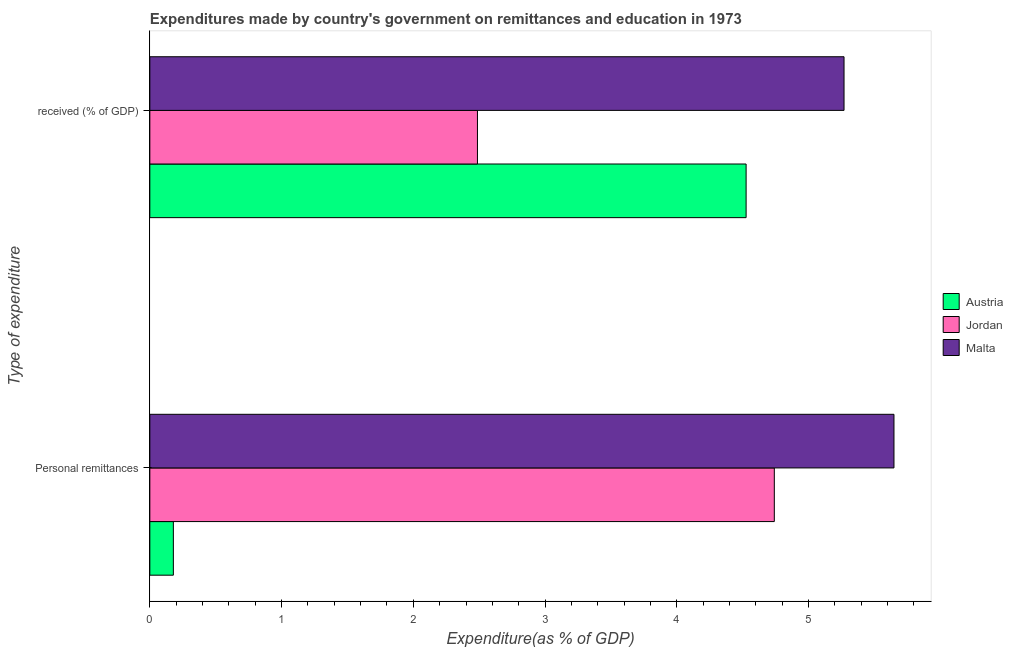How many groups of bars are there?
Provide a succinct answer. 2. Are the number of bars per tick equal to the number of legend labels?
Provide a short and direct response. Yes. How many bars are there on the 2nd tick from the top?
Offer a terse response. 3. What is the label of the 2nd group of bars from the top?
Your response must be concise. Personal remittances. What is the expenditure in education in Malta?
Your response must be concise. 5.27. Across all countries, what is the maximum expenditure in education?
Keep it short and to the point. 5.27. Across all countries, what is the minimum expenditure in personal remittances?
Offer a terse response. 0.18. In which country was the expenditure in education maximum?
Offer a terse response. Malta. In which country was the expenditure in personal remittances minimum?
Provide a succinct answer. Austria. What is the total expenditure in education in the graph?
Your response must be concise. 12.28. What is the difference between the expenditure in personal remittances in Malta and that in Austria?
Offer a terse response. 5.47. What is the difference between the expenditure in personal remittances in Jordan and the expenditure in education in Malta?
Provide a succinct answer. -0.53. What is the average expenditure in education per country?
Give a very brief answer. 4.09. What is the difference between the expenditure in education and expenditure in personal remittances in Austria?
Provide a succinct answer. 4.35. In how many countries, is the expenditure in personal remittances greater than 0.8 %?
Your response must be concise. 2. What is the ratio of the expenditure in education in Austria to that in Jordan?
Offer a terse response. 1.82. Is the expenditure in personal remittances in Malta less than that in Austria?
Give a very brief answer. No. What does the 2nd bar from the top in  received (% of GDP) represents?
Your answer should be very brief. Jordan. What does the 2nd bar from the bottom in  received (% of GDP) represents?
Your response must be concise. Jordan. How many bars are there?
Ensure brevity in your answer.  6. What is the difference between two consecutive major ticks on the X-axis?
Offer a terse response. 1. Does the graph contain grids?
Provide a short and direct response. No. How are the legend labels stacked?
Offer a very short reply. Vertical. What is the title of the graph?
Your response must be concise. Expenditures made by country's government on remittances and education in 1973. What is the label or title of the X-axis?
Give a very brief answer. Expenditure(as % of GDP). What is the label or title of the Y-axis?
Give a very brief answer. Type of expenditure. What is the Expenditure(as % of GDP) in Austria in Personal remittances?
Provide a succinct answer. 0.18. What is the Expenditure(as % of GDP) of Jordan in Personal remittances?
Ensure brevity in your answer.  4.74. What is the Expenditure(as % of GDP) of Malta in Personal remittances?
Keep it short and to the point. 5.65. What is the Expenditure(as % of GDP) of Austria in  received (% of GDP)?
Offer a terse response. 4.53. What is the Expenditure(as % of GDP) of Jordan in  received (% of GDP)?
Your answer should be very brief. 2.49. What is the Expenditure(as % of GDP) in Malta in  received (% of GDP)?
Keep it short and to the point. 5.27. Across all Type of expenditure, what is the maximum Expenditure(as % of GDP) in Austria?
Provide a succinct answer. 4.53. Across all Type of expenditure, what is the maximum Expenditure(as % of GDP) in Jordan?
Your answer should be compact. 4.74. Across all Type of expenditure, what is the maximum Expenditure(as % of GDP) of Malta?
Offer a very short reply. 5.65. Across all Type of expenditure, what is the minimum Expenditure(as % of GDP) in Austria?
Make the answer very short. 0.18. Across all Type of expenditure, what is the minimum Expenditure(as % of GDP) of Jordan?
Make the answer very short. 2.49. Across all Type of expenditure, what is the minimum Expenditure(as % of GDP) in Malta?
Offer a terse response. 5.27. What is the total Expenditure(as % of GDP) of Austria in the graph?
Your answer should be compact. 4.71. What is the total Expenditure(as % of GDP) in Jordan in the graph?
Make the answer very short. 7.23. What is the total Expenditure(as % of GDP) in Malta in the graph?
Offer a terse response. 10.92. What is the difference between the Expenditure(as % of GDP) of Austria in Personal remittances and that in  received (% of GDP)?
Your answer should be compact. -4.35. What is the difference between the Expenditure(as % of GDP) in Jordan in Personal remittances and that in  received (% of GDP)?
Your answer should be very brief. 2.25. What is the difference between the Expenditure(as % of GDP) in Malta in Personal remittances and that in  received (% of GDP)?
Give a very brief answer. 0.38. What is the difference between the Expenditure(as % of GDP) in Austria in Personal remittances and the Expenditure(as % of GDP) in Jordan in  received (% of GDP)?
Offer a very short reply. -2.31. What is the difference between the Expenditure(as % of GDP) in Austria in Personal remittances and the Expenditure(as % of GDP) in Malta in  received (% of GDP)?
Give a very brief answer. -5.09. What is the difference between the Expenditure(as % of GDP) in Jordan in Personal remittances and the Expenditure(as % of GDP) in Malta in  received (% of GDP)?
Your answer should be compact. -0.53. What is the average Expenditure(as % of GDP) of Austria per Type of expenditure?
Keep it short and to the point. 2.35. What is the average Expenditure(as % of GDP) in Jordan per Type of expenditure?
Provide a succinct answer. 3.61. What is the average Expenditure(as % of GDP) of Malta per Type of expenditure?
Offer a very short reply. 5.46. What is the difference between the Expenditure(as % of GDP) in Austria and Expenditure(as % of GDP) in Jordan in Personal remittances?
Your answer should be compact. -4.56. What is the difference between the Expenditure(as % of GDP) of Austria and Expenditure(as % of GDP) of Malta in Personal remittances?
Make the answer very short. -5.47. What is the difference between the Expenditure(as % of GDP) of Jordan and Expenditure(as % of GDP) of Malta in Personal remittances?
Provide a succinct answer. -0.91. What is the difference between the Expenditure(as % of GDP) in Austria and Expenditure(as % of GDP) in Jordan in  received (% of GDP)?
Make the answer very short. 2.04. What is the difference between the Expenditure(as % of GDP) in Austria and Expenditure(as % of GDP) in Malta in  received (% of GDP)?
Ensure brevity in your answer.  -0.74. What is the difference between the Expenditure(as % of GDP) of Jordan and Expenditure(as % of GDP) of Malta in  received (% of GDP)?
Provide a succinct answer. -2.78. What is the ratio of the Expenditure(as % of GDP) of Austria in Personal remittances to that in  received (% of GDP)?
Provide a short and direct response. 0.04. What is the ratio of the Expenditure(as % of GDP) of Jordan in Personal remittances to that in  received (% of GDP)?
Keep it short and to the point. 1.91. What is the ratio of the Expenditure(as % of GDP) in Malta in Personal remittances to that in  received (% of GDP)?
Your answer should be compact. 1.07. What is the difference between the highest and the second highest Expenditure(as % of GDP) in Austria?
Offer a very short reply. 4.35. What is the difference between the highest and the second highest Expenditure(as % of GDP) in Jordan?
Offer a very short reply. 2.25. What is the difference between the highest and the second highest Expenditure(as % of GDP) in Malta?
Offer a terse response. 0.38. What is the difference between the highest and the lowest Expenditure(as % of GDP) of Austria?
Ensure brevity in your answer.  4.35. What is the difference between the highest and the lowest Expenditure(as % of GDP) of Jordan?
Your response must be concise. 2.25. What is the difference between the highest and the lowest Expenditure(as % of GDP) of Malta?
Offer a terse response. 0.38. 